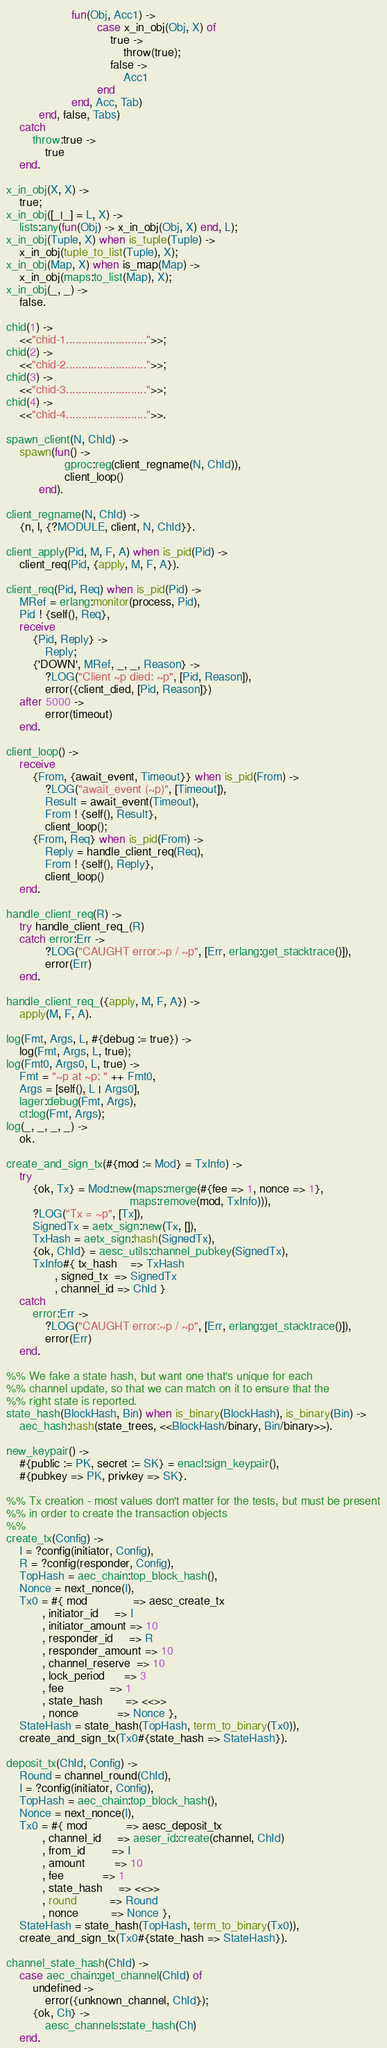<code> <loc_0><loc_0><loc_500><loc_500><_Erlang_>                    fun(Obj, Acc1) ->
                            case x_in_obj(Obj, X) of
                                true ->
                                    throw(true);
                                false ->
                                    Acc1
                            end
                    end, Acc, Tab)
          end, false, Tabs)
    catch
        throw:true ->
            true
    end.

x_in_obj(X, X) ->
    true;
x_in_obj([_|_] = L, X) ->
    lists:any(fun(Obj) -> x_in_obj(Obj, X) end, L);
x_in_obj(Tuple, X) when is_tuple(Tuple) ->
    x_in_obj(tuple_to_list(Tuple), X);
x_in_obj(Map, X) when is_map(Map) ->
    x_in_obj(maps:to_list(Map), X);
x_in_obj(_, _) ->
    false.

chid(1) ->
    <<"chid-1..........................">>;
chid(2) ->
    <<"chid-2..........................">>;
chid(3) ->
    <<"chid-3..........................">>;
chid(4) ->
    <<"chid-4..........................">>.

spawn_client(N, ChId) ->
    spawn(fun() ->
                  gproc:reg(client_regname(N, ChId)),
                  client_loop()
          end).

client_regname(N, ChId) ->
    {n, l, {?MODULE, client, N, ChId}}.

client_apply(Pid, M, F, A) when is_pid(Pid) ->
    client_req(Pid, {apply, M, F, A}).

client_req(Pid, Req) when is_pid(Pid) ->
    MRef = erlang:monitor(process, Pid),
    Pid ! {self(), Req},
    receive
        {Pid, Reply} ->
            Reply;
        {'DOWN', MRef, _, _, Reason} ->
            ?LOG("Client ~p died: ~p", [Pid, Reason]),
            error({client_died, [Pid, Reason]})
    after 5000 ->
            error(timeout)
    end.

client_loop() ->
    receive
        {From, {await_event, Timeout}} when is_pid(From) ->
            ?LOG("await_event (~p)", [Timeout]),
            Result = await_event(Timeout),
            From ! {self(), Result},
            client_loop();
        {From, Req} when is_pid(From) ->
            Reply = handle_client_req(Req),
            From ! {self(), Reply},
            client_loop()
    end.

handle_client_req(R) ->
    try handle_client_req_(R)
    catch error:Err ->
            ?LOG("CAUGHT error:~p / ~p", [Err, erlang:get_stacktrace()]),
            error(Err)
    end.

handle_client_req_({apply, M, F, A}) ->
    apply(M, F, A).

log(Fmt, Args, L, #{debug := true}) ->
    log(Fmt, Args, L, true);
log(Fmt0, Args0, L, true) ->
    Fmt = "~p at ~p: " ++ Fmt0,
    Args = [self(), L | Args0],
    lager:debug(Fmt, Args),
    ct:log(Fmt, Args);
log(_, _, _, _) ->
    ok.

create_and_sign_tx(#{mod := Mod} = TxInfo) ->
    try
        {ok, Tx} = Mod:new(maps:merge(#{fee => 1, nonce => 1},
                                      maps:remove(mod, TxInfo))),
        ?LOG("Tx = ~p", [Tx]),
        SignedTx = aetx_sign:new(Tx, []),
        TxHash = aetx_sign:hash(SignedTx),
        {ok, ChId} = aesc_utils:channel_pubkey(SignedTx),
        TxInfo#{ tx_hash    => TxHash
               , signed_tx  => SignedTx
               , channel_id => ChId }
    catch
        error:Err ->
            ?LOG("CAUGHT error:~p / ~p", [Err, erlang:get_stacktrace()]),
            error(Err)
    end.

%% We fake a state hash, but want one that's unique for each
%% channel update, so that we can match on it to ensure that the
%% right state is reported.
state_hash(BlockHash, Bin) when is_binary(BlockHash), is_binary(Bin) ->
    aec_hash:hash(state_trees, <<BlockHash/binary, Bin/binary>>).

new_keypair() ->
    #{public := PK, secret := SK} = enacl:sign_keypair(),
    #{pubkey => PK, privkey => SK}.

%% Tx creation - most values don't matter for the tests, but must be present
%% in order to create the transaction objects
%%
create_tx(Config) ->
    I = ?config(initiator, Config),
    R = ?config(responder, Config),
    TopHash = aec_chain:top_block_hash(),
    Nonce = next_nonce(I),
    Tx0 = #{ mod              => aesc_create_tx
           , initiator_id     => I
           , initiator_amount => 10
           , responder_id     => R
           , responder_amount => 10
           , channel_reserve  => 10
           , lock_period      => 3
           , fee              => 1
           , state_hash       => <<>>
           , nonce            => Nonce },
    StateHash = state_hash(TopHash, term_to_binary(Tx0)),
    create_and_sign_tx(Tx0#{state_hash => StateHash}).

deposit_tx(ChId, Config) ->
    Round = channel_round(ChId),
    I = ?config(initiator, Config),
    TopHash = aec_chain:top_block_hash(),
    Nonce = next_nonce(I),
    Tx0 = #{ mod            => aesc_deposit_tx
           , channel_id     => aeser_id:create(channel, ChId)
           , from_id        => I
           , amount         => 10
           , fee            => 1
           , state_hash     => <<>>
           , round          => Round
           , nonce          => Nonce },
    StateHash = state_hash(TopHash, term_to_binary(Tx0)),
    create_and_sign_tx(Tx0#{state_hash => StateHash}).

channel_state_hash(ChId) ->
    case aec_chain:get_channel(ChId) of
        undefined ->
            error({unknown_channel, ChId});
        {ok, Ch} ->
            aesc_channels:state_hash(Ch)
    end.
</code> 